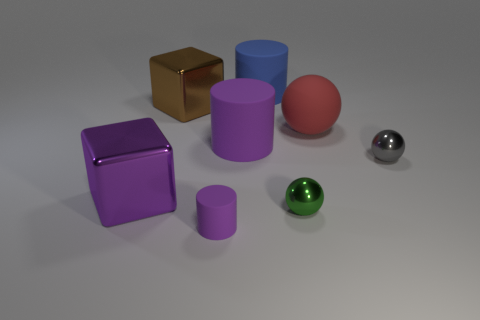What number of spheres are red metallic objects or blue matte things? In the image, there are a total of two spheres; however, neither of these spheres are red metallic or blue matte. The spheres are pink and silver colored. 